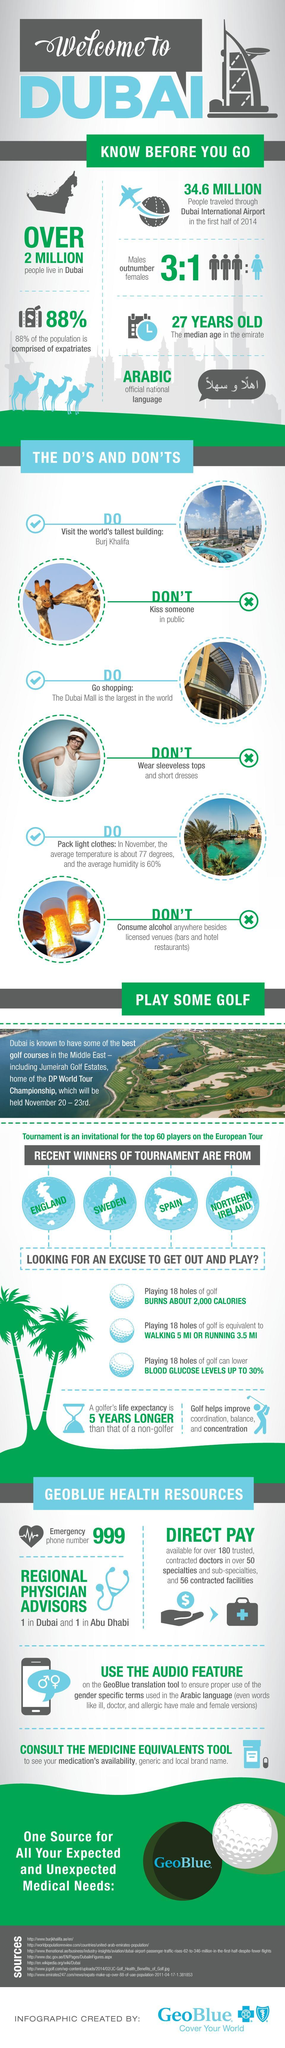If taking a sample of 4 people in Dubai, how many are males?
Answer the question with a short phrase. 3 What is not allowed to put in Dubai? sleeveless tops and short dresses How many Do's are listed in the infographic? 3 If taking a sample of 4 people in Dubai, how many are females? 1 What is the second "Do" mentioned in the infographic? Go shopping How many Don'ts are listed in the infographic? 3 How many points listed in the infographic are favoring Golf play? 3 What is the color code given to Females- red, pink, blue, yellow? blue What percentage of Dubai population are the people from Dubai itself? 12 Which is the third country listed among tournament winners? Spain 